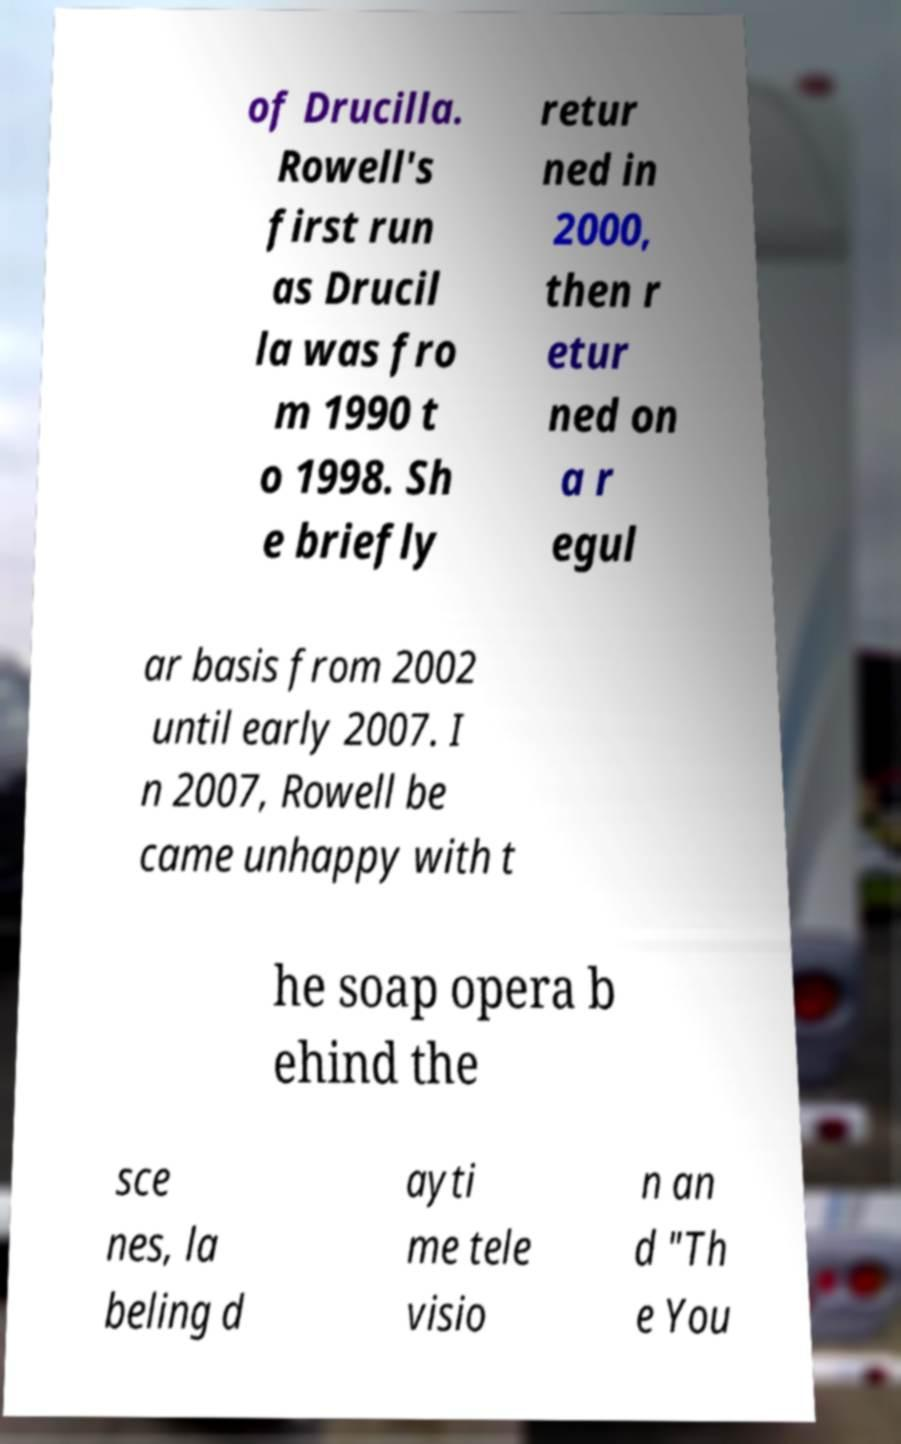There's text embedded in this image that I need extracted. Can you transcribe it verbatim? of Drucilla. Rowell's first run as Drucil la was fro m 1990 t o 1998. Sh e briefly retur ned in 2000, then r etur ned on a r egul ar basis from 2002 until early 2007. I n 2007, Rowell be came unhappy with t he soap opera b ehind the sce nes, la beling d ayti me tele visio n an d "Th e You 